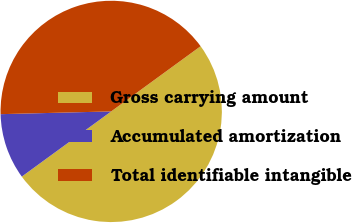Convert chart to OTSL. <chart><loc_0><loc_0><loc_500><loc_500><pie_chart><fcel>Gross carrying amount<fcel>Accumulated amortization<fcel>Total identifiable intangible<nl><fcel>50.0%<fcel>9.63%<fcel>40.37%<nl></chart> 